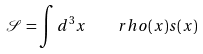<formula> <loc_0><loc_0><loc_500><loc_500>\mathcal { S } = \int d ^ { 3 } x \quad r h o ( x ) s ( x )</formula> 